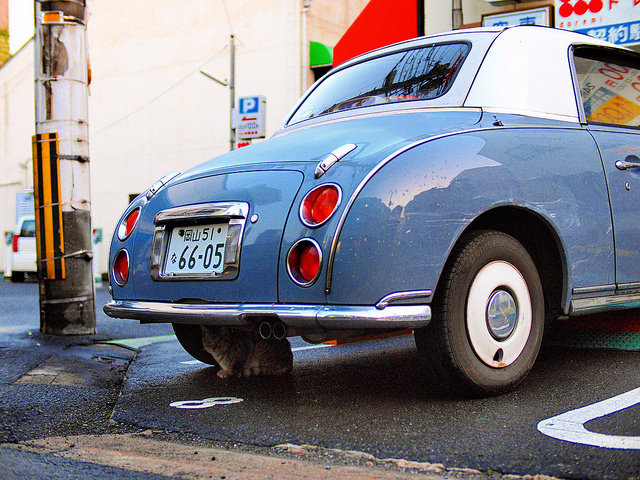<image>What brand of vehicle is this? It is unknown what brand the vehicle is. It could be BMW, Volkswagen, Fiat, Nissan, Jaguar, or Ford. What brand of vehicle is this? I don't know the exact brand of the vehicle. It can be BMW, Volkswagen, Fiat, Nissan, Jaguar, or Ford. 